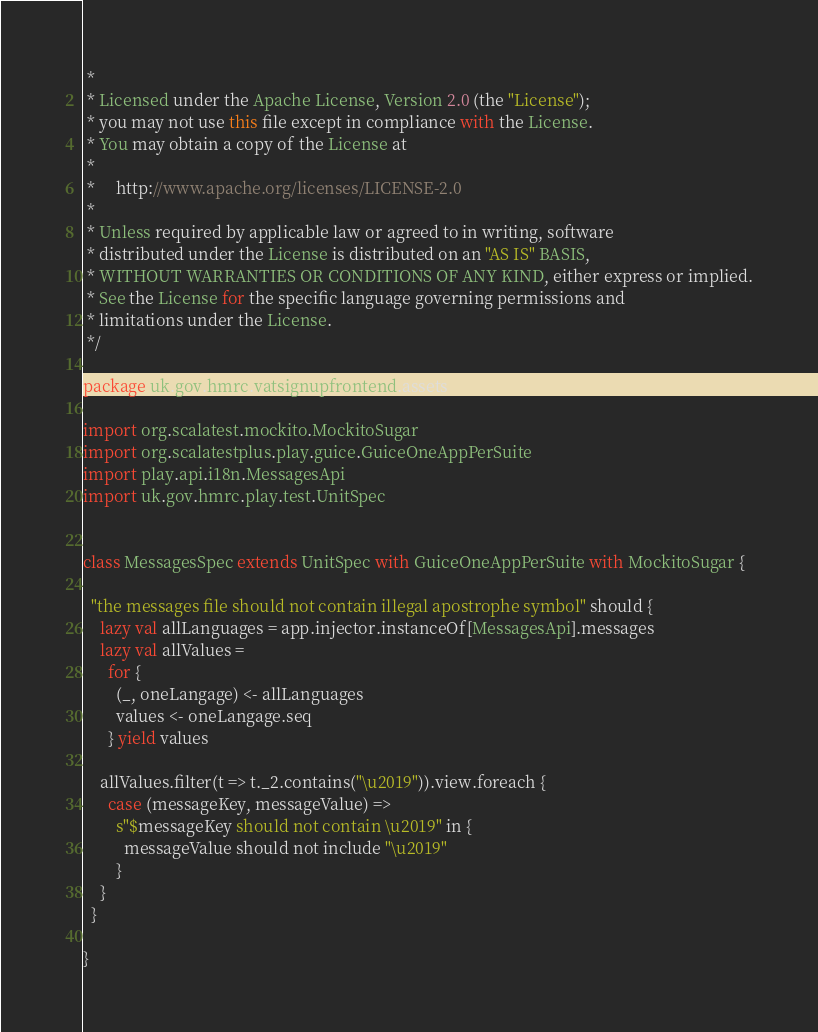Convert code to text. <code><loc_0><loc_0><loc_500><loc_500><_Scala_> *
 * Licensed under the Apache License, Version 2.0 (the "License");
 * you may not use this file except in compliance with the License.
 * You may obtain a copy of the License at
 *
 *     http://www.apache.org/licenses/LICENSE-2.0
 *
 * Unless required by applicable law or agreed to in writing, software
 * distributed under the License is distributed on an "AS IS" BASIS,
 * WITHOUT WARRANTIES OR CONDITIONS OF ANY KIND, either express or implied.
 * See the License for the specific language governing permissions and
 * limitations under the License.
 */

package uk.gov.hmrc.vatsignupfrontend.assets

import org.scalatest.mockito.MockitoSugar
import org.scalatestplus.play.guice.GuiceOneAppPerSuite
import play.api.i18n.MessagesApi
import uk.gov.hmrc.play.test.UnitSpec


class MessagesSpec extends UnitSpec with GuiceOneAppPerSuite with MockitoSugar {

  "the messages file should not contain illegal apostrophe symbol" should {
    lazy val allLanguages = app.injector.instanceOf[MessagesApi].messages
    lazy val allValues =
      for {
        (_, oneLangage) <- allLanguages
        values <- oneLangage.seq
      } yield values

    allValues.filter(t => t._2.contains("\u2019")).view.foreach {
      case (messageKey, messageValue) =>
        s"$messageKey should not contain \u2019" in {
          messageValue should not include "\u2019"
        }
    }
  }

}
</code> 